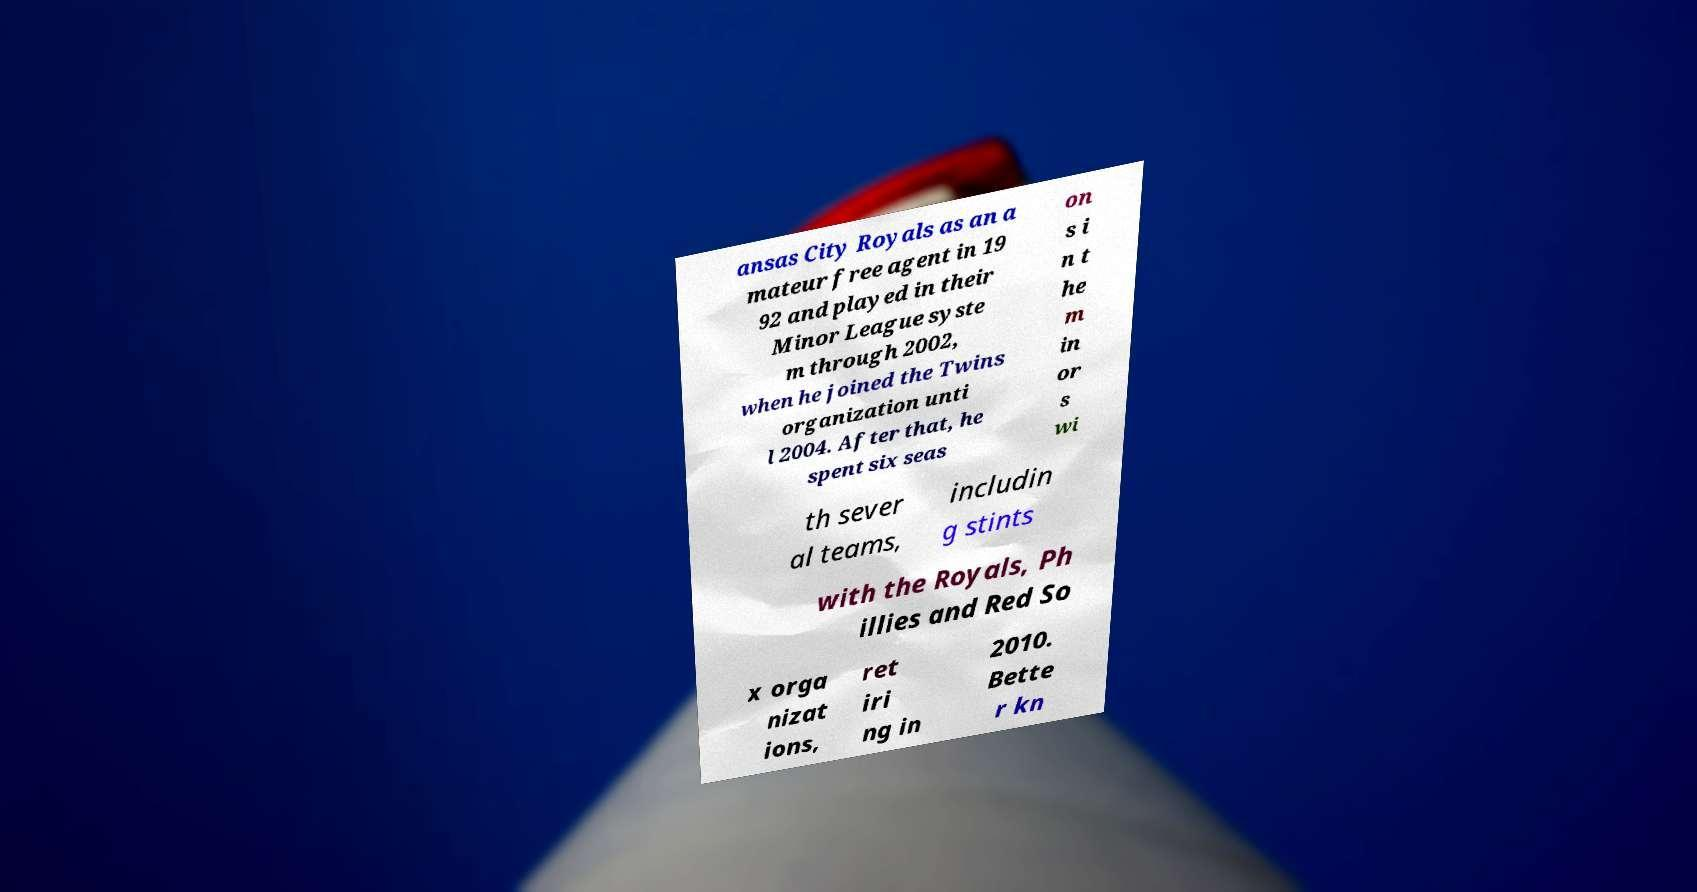There's text embedded in this image that I need extracted. Can you transcribe it verbatim? ansas City Royals as an a mateur free agent in 19 92 and played in their Minor League syste m through 2002, when he joined the Twins organization unti l 2004. After that, he spent six seas on s i n t he m in or s wi th sever al teams, includin g stints with the Royals, Ph illies and Red So x orga nizat ions, ret iri ng in 2010. Bette r kn 